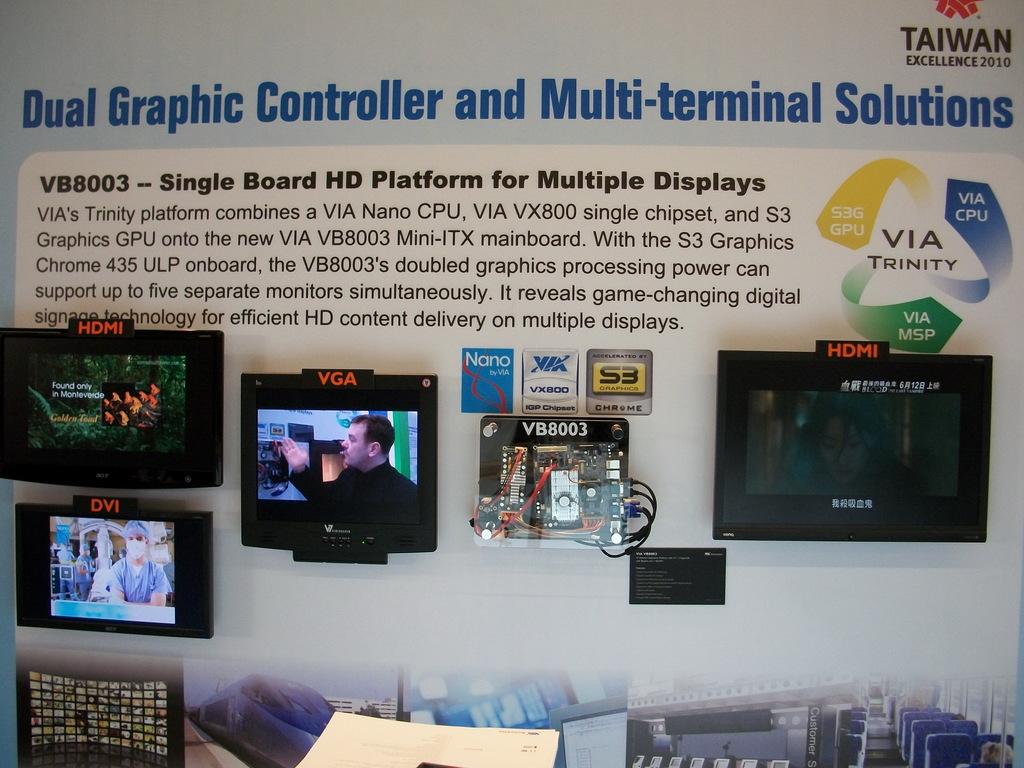What is the text in the middle of the three arrows?
Offer a very short reply. Via trinity. 